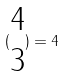Convert formula to latex. <formula><loc_0><loc_0><loc_500><loc_500>( \begin{matrix} 4 \\ 3 \end{matrix} ) = 4</formula> 